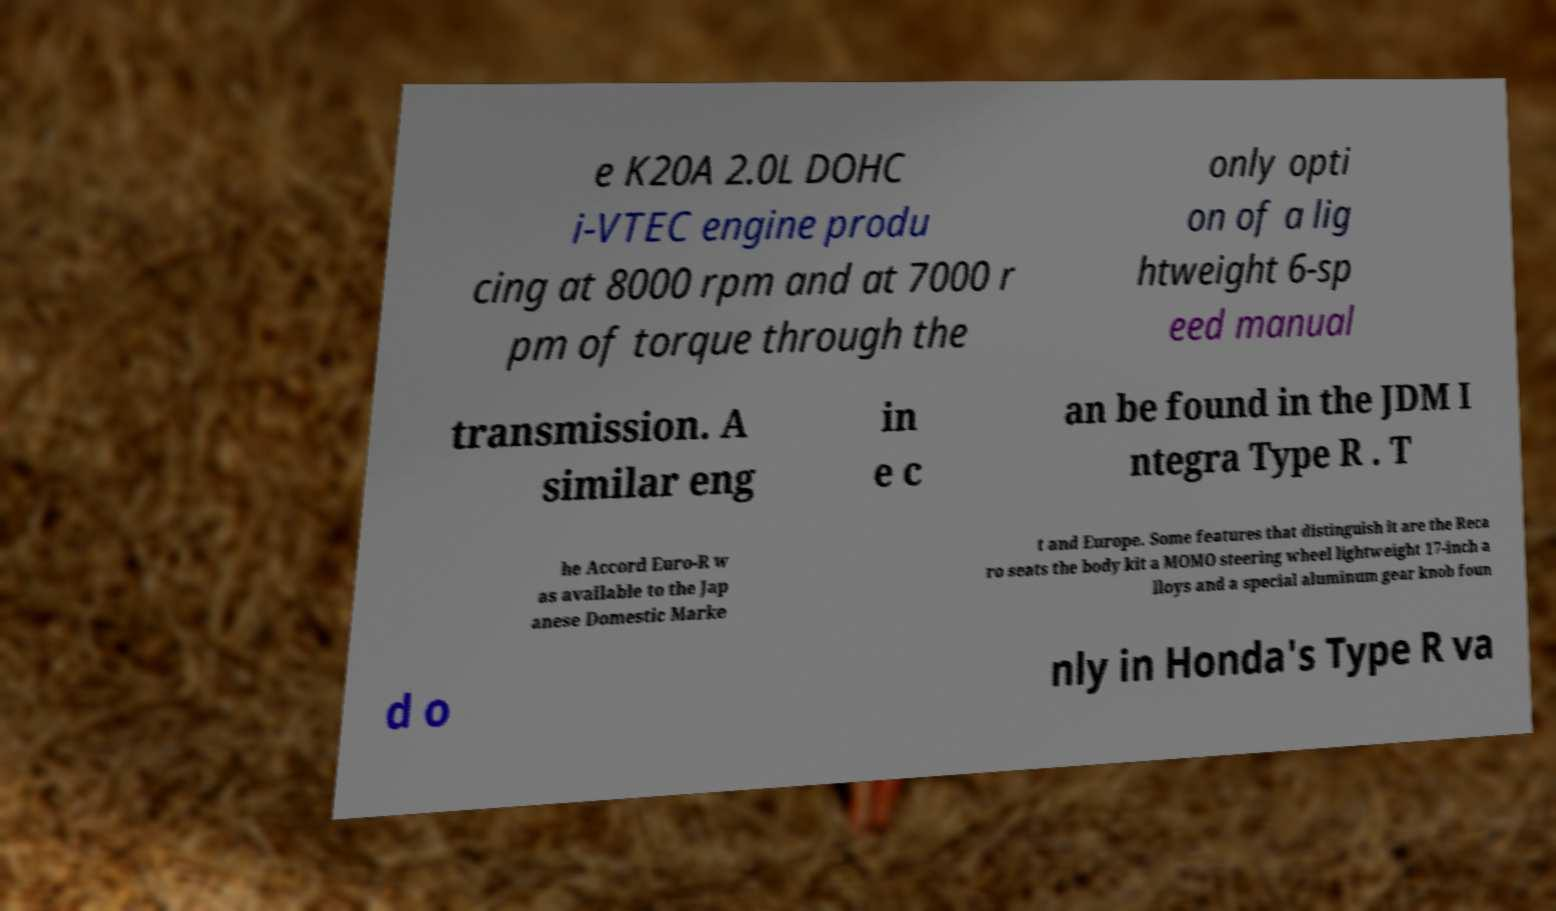Can you read and provide the text displayed in the image?This photo seems to have some interesting text. Can you extract and type it out for me? e K20A 2.0L DOHC i-VTEC engine produ cing at 8000 rpm and at 7000 r pm of torque through the only opti on of a lig htweight 6-sp eed manual transmission. A similar eng in e c an be found in the JDM I ntegra Type R . T he Accord Euro-R w as available to the Jap anese Domestic Marke t and Europe. Some features that distinguish it are the Reca ro seats the body kit a MOMO steering wheel lightweight 17-inch a lloys and a special aluminum gear knob foun d o nly in Honda's Type R va 